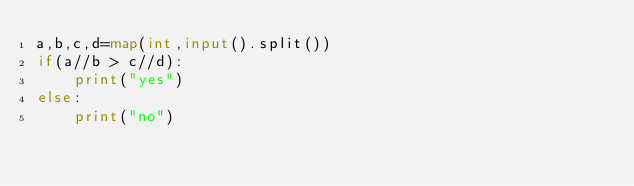Convert code to text. <code><loc_0><loc_0><loc_500><loc_500><_Python_>a,b,c,d=map(int,input().split())
if(a//b > c//d):
    print("yes")
else:
    print("no")</code> 